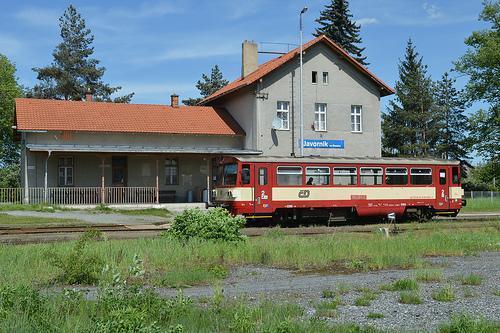How many vehicles are in the picture?
Give a very brief answer. 1. 